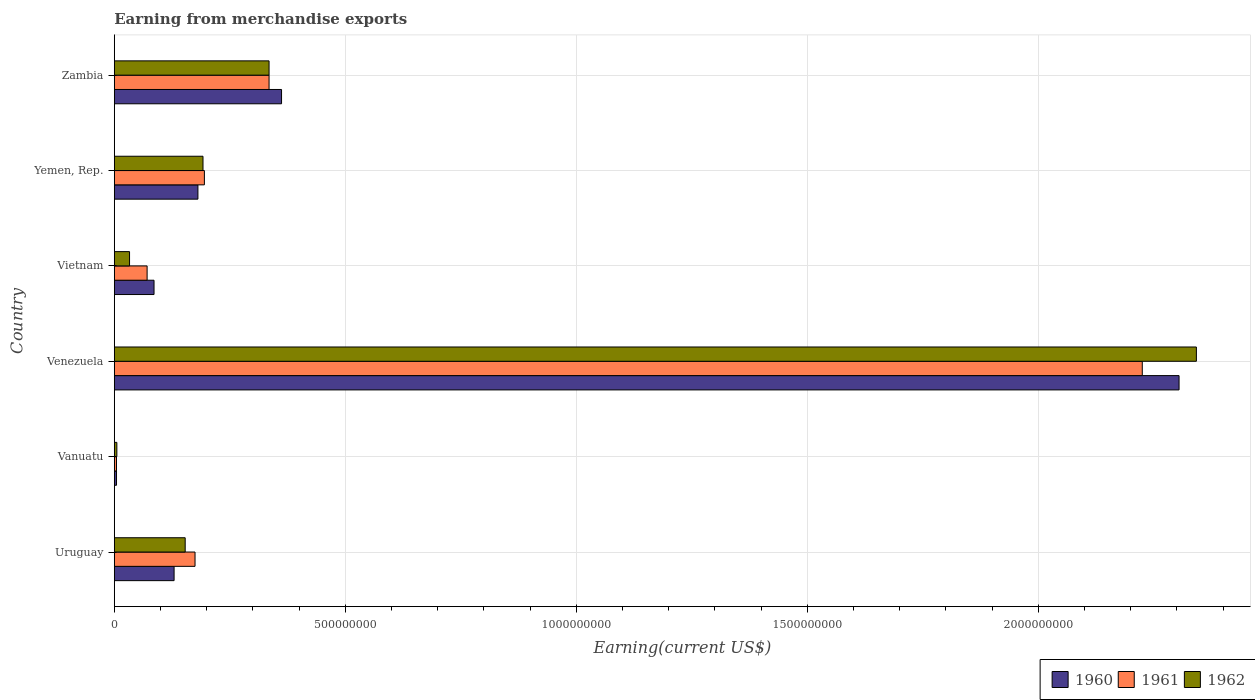How many different coloured bars are there?
Offer a terse response. 3. How many groups of bars are there?
Provide a succinct answer. 6. How many bars are there on the 5th tick from the bottom?
Give a very brief answer. 3. What is the label of the 5th group of bars from the top?
Provide a short and direct response. Vanuatu. In how many cases, is the number of bars for a given country not equal to the number of legend labels?
Provide a succinct answer. 0. What is the amount earned from merchandise exports in 1960 in Venezuela?
Give a very brief answer. 2.30e+09. Across all countries, what is the maximum amount earned from merchandise exports in 1961?
Make the answer very short. 2.23e+09. Across all countries, what is the minimum amount earned from merchandise exports in 1960?
Provide a short and direct response. 4.78e+06. In which country was the amount earned from merchandise exports in 1960 maximum?
Provide a succinct answer. Venezuela. In which country was the amount earned from merchandise exports in 1962 minimum?
Offer a terse response. Vanuatu. What is the total amount earned from merchandise exports in 1960 in the graph?
Your answer should be compact. 3.07e+09. What is the difference between the amount earned from merchandise exports in 1960 in Vietnam and that in Yemen, Rep.?
Make the answer very short. -9.50e+07. What is the difference between the amount earned from merchandise exports in 1962 in Uruguay and the amount earned from merchandise exports in 1961 in Vanuatu?
Your answer should be very brief. 1.49e+08. What is the average amount earned from merchandise exports in 1962 per country?
Keep it short and to the point. 5.10e+08. What is the difference between the amount earned from merchandise exports in 1962 and amount earned from merchandise exports in 1961 in Vietnam?
Give a very brief answer. -3.80e+07. In how many countries, is the amount earned from merchandise exports in 1961 greater than 2000000000 US$?
Keep it short and to the point. 1. What is the ratio of the amount earned from merchandise exports in 1961 in Uruguay to that in Vanuatu?
Your answer should be compact. 36.96. Is the amount earned from merchandise exports in 1962 in Vietnam less than that in Yemen, Rep.?
Give a very brief answer. Yes. Is the difference between the amount earned from merchandise exports in 1962 in Uruguay and Zambia greater than the difference between the amount earned from merchandise exports in 1961 in Uruguay and Zambia?
Offer a terse response. No. What is the difference between the highest and the second highest amount earned from merchandise exports in 1961?
Offer a terse response. 1.89e+09. What is the difference between the highest and the lowest amount earned from merchandise exports in 1960?
Your answer should be compact. 2.30e+09. In how many countries, is the amount earned from merchandise exports in 1961 greater than the average amount earned from merchandise exports in 1961 taken over all countries?
Offer a terse response. 1. Is the sum of the amount earned from merchandise exports in 1961 in Vanuatu and Yemen, Rep. greater than the maximum amount earned from merchandise exports in 1962 across all countries?
Ensure brevity in your answer.  No. What does the 1st bar from the bottom in Venezuela represents?
Provide a succinct answer. 1960. Is it the case that in every country, the sum of the amount earned from merchandise exports in 1960 and amount earned from merchandise exports in 1962 is greater than the amount earned from merchandise exports in 1961?
Offer a terse response. Yes. How many bars are there?
Offer a very short reply. 18. How many countries are there in the graph?
Your response must be concise. 6. What is the difference between two consecutive major ticks on the X-axis?
Your answer should be very brief. 5.00e+08. Are the values on the major ticks of X-axis written in scientific E-notation?
Keep it short and to the point. No. Does the graph contain any zero values?
Ensure brevity in your answer.  No. Where does the legend appear in the graph?
Provide a short and direct response. Bottom right. How many legend labels are there?
Keep it short and to the point. 3. How are the legend labels stacked?
Keep it short and to the point. Horizontal. What is the title of the graph?
Make the answer very short. Earning from merchandise exports. What is the label or title of the X-axis?
Offer a terse response. Earning(current US$). What is the Earning(current US$) in 1960 in Uruguay?
Your answer should be very brief. 1.29e+08. What is the Earning(current US$) in 1961 in Uruguay?
Provide a succinct answer. 1.75e+08. What is the Earning(current US$) in 1962 in Uruguay?
Your response must be concise. 1.53e+08. What is the Earning(current US$) in 1960 in Vanuatu?
Your answer should be compact. 4.78e+06. What is the Earning(current US$) of 1961 in Vanuatu?
Offer a terse response. 4.73e+06. What is the Earning(current US$) of 1962 in Vanuatu?
Your answer should be very brief. 5.52e+06. What is the Earning(current US$) in 1960 in Venezuela?
Offer a very short reply. 2.30e+09. What is the Earning(current US$) of 1961 in Venezuela?
Keep it short and to the point. 2.23e+09. What is the Earning(current US$) of 1962 in Venezuela?
Make the answer very short. 2.34e+09. What is the Earning(current US$) of 1960 in Vietnam?
Provide a succinct answer. 8.60e+07. What is the Earning(current US$) in 1961 in Vietnam?
Keep it short and to the point. 7.10e+07. What is the Earning(current US$) of 1962 in Vietnam?
Your answer should be compact. 3.30e+07. What is the Earning(current US$) in 1960 in Yemen, Rep.?
Your response must be concise. 1.81e+08. What is the Earning(current US$) of 1961 in Yemen, Rep.?
Ensure brevity in your answer.  1.95e+08. What is the Earning(current US$) of 1962 in Yemen, Rep.?
Provide a succinct answer. 1.92e+08. What is the Earning(current US$) of 1960 in Zambia?
Your answer should be very brief. 3.62e+08. What is the Earning(current US$) of 1961 in Zambia?
Your response must be concise. 3.35e+08. What is the Earning(current US$) of 1962 in Zambia?
Provide a short and direct response. 3.35e+08. Across all countries, what is the maximum Earning(current US$) in 1960?
Give a very brief answer. 2.30e+09. Across all countries, what is the maximum Earning(current US$) in 1961?
Your answer should be compact. 2.23e+09. Across all countries, what is the maximum Earning(current US$) of 1962?
Give a very brief answer. 2.34e+09. Across all countries, what is the minimum Earning(current US$) in 1960?
Keep it short and to the point. 4.78e+06. Across all countries, what is the minimum Earning(current US$) in 1961?
Provide a short and direct response. 4.73e+06. Across all countries, what is the minimum Earning(current US$) in 1962?
Offer a terse response. 5.52e+06. What is the total Earning(current US$) in 1960 in the graph?
Offer a terse response. 3.07e+09. What is the total Earning(current US$) of 1961 in the graph?
Keep it short and to the point. 3.01e+09. What is the total Earning(current US$) in 1962 in the graph?
Ensure brevity in your answer.  3.06e+09. What is the difference between the Earning(current US$) of 1960 in Uruguay and that in Vanuatu?
Make the answer very short. 1.25e+08. What is the difference between the Earning(current US$) in 1961 in Uruguay and that in Vanuatu?
Provide a short and direct response. 1.70e+08. What is the difference between the Earning(current US$) in 1962 in Uruguay and that in Vanuatu?
Offer a very short reply. 1.48e+08. What is the difference between the Earning(current US$) of 1960 in Uruguay and that in Venezuela?
Your answer should be compact. -2.18e+09. What is the difference between the Earning(current US$) of 1961 in Uruguay and that in Venezuela?
Your response must be concise. -2.05e+09. What is the difference between the Earning(current US$) of 1962 in Uruguay and that in Venezuela?
Make the answer very short. -2.19e+09. What is the difference between the Earning(current US$) of 1960 in Uruguay and that in Vietnam?
Offer a very short reply. 4.34e+07. What is the difference between the Earning(current US$) in 1961 in Uruguay and that in Vietnam?
Keep it short and to the point. 1.04e+08. What is the difference between the Earning(current US$) in 1962 in Uruguay and that in Vietnam?
Keep it short and to the point. 1.20e+08. What is the difference between the Earning(current US$) in 1960 in Uruguay and that in Yemen, Rep.?
Give a very brief answer. -5.16e+07. What is the difference between the Earning(current US$) in 1961 in Uruguay and that in Yemen, Rep.?
Offer a terse response. -2.03e+07. What is the difference between the Earning(current US$) in 1962 in Uruguay and that in Yemen, Rep.?
Offer a terse response. -3.86e+07. What is the difference between the Earning(current US$) in 1960 in Uruguay and that in Zambia?
Offer a terse response. -2.33e+08. What is the difference between the Earning(current US$) of 1961 in Uruguay and that in Zambia?
Offer a very short reply. -1.60e+08. What is the difference between the Earning(current US$) of 1962 in Uruguay and that in Zambia?
Give a very brief answer. -1.82e+08. What is the difference between the Earning(current US$) of 1960 in Vanuatu and that in Venezuela?
Ensure brevity in your answer.  -2.30e+09. What is the difference between the Earning(current US$) in 1961 in Vanuatu and that in Venezuela?
Your response must be concise. -2.22e+09. What is the difference between the Earning(current US$) of 1962 in Vanuatu and that in Venezuela?
Provide a short and direct response. -2.34e+09. What is the difference between the Earning(current US$) in 1960 in Vanuatu and that in Vietnam?
Make the answer very short. -8.12e+07. What is the difference between the Earning(current US$) of 1961 in Vanuatu and that in Vietnam?
Provide a succinct answer. -6.63e+07. What is the difference between the Earning(current US$) of 1962 in Vanuatu and that in Vietnam?
Provide a short and direct response. -2.75e+07. What is the difference between the Earning(current US$) in 1960 in Vanuatu and that in Yemen, Rep.?
Offer a terse response. -1.76e+08. What is the difference between the Earning(current US$) of 1961 in Vanuatu and that in Yemen, Rep.?
Offer a terse response. -1.90e+08. What is the difference between the Earning(current US$) in 1962 in Vanuatu and that in Yemen, Rep.?
Give a very brief answer. -1.86e+08. What is the difference between the Earning(current US$) of 1960 in Vanuatu and that in Zambia?
Make the answer very short. -3.57e+08. What is the difference between the Earning(current US$) of 1961 in Vanuatu and that in Zambia?
Offer a terse response. -3.30e+08. What is the difference between the Earning(current US$) in 1962 in Vanuatu and that in Zambia?
Your answer should be very brief. -3.29e+08. What is the difference between the Earning(current US$) in 1960 in Venezuela and that in Vietnam?
Ensure brevity in your answer.  2.22e+09. What is the difference between the Earning(current US$) of 1961 in Venezuela and that in Vietnam?
Your answer should be compact. 2.15e+09. What is the difference between the Earning(current US$) of 1962 in Venezuela and that in Vietnam?
Your answer should be very brief. 2.31e+09. What is the difference between the Earning(current US$) in 1960 in Venezuela and that in Yemen, Rep.?
Provide a short and direct response. 2.12e+09. What is the difference between the Earning(current US$) in 1961 in Venezuela and that in Yemen, Rep.?
Provide a short and direct response. 2.03e+09. What is the difference between the Earning(current US$) of 1962 in Venezuela and that in Yemen, Rep.?
Make the answer very short. 2.15e+09. What is the difference between the Earning(current US$) of 1960 in Venezuela and that in Zambia?
Give a very brief answer. 1.94e+09. What is the difference between the Earning(current US$) in 1961 in Venezuela and that in Zambia?
Keep it short and to the point. 1.89e+09. What is the difference between the Earning(current US$) of 1962 in Venezuela and that in Zambia?
Ensure brevity in your answer.  2.01e+09. What is the difference between the Earning(current US$) of 1960 in Vietnam and that in Yemen, Rep.?
Your answer should be compact. -9.50e+07. What is the difference between the Earning(current US$) of 1961 in Vietnam and that in Yemen, Rep.?
Keep it short and to the point. -1.24e+08. What is the difference between the Earning(current US$) in 1962 in Vietnam and that in Yemen, Rep.?
Provide a succinct answer. -1.59e+08. What is the difference between the Earning(current US$) in 1960 in Vietnam and that in Zambia?
Ensure brevity in your answer.  -2.76e+08. What is the difference between the Earning(current US$) of 1961 in Vietnam and that in Zambia?
Offer a terse response. -2.64e+08. What is the difference between the Earning(current US$) of 1962 in Vietnam and that in Zambia?
Your response must be concise. -3.02e+08. What is the difference between the Earning(current US$) in 1960 in Yemen, Rep. and that in Zambia?
Offer a terse response. -1.81e+08. What is the difference between the Earning(current US$) in 1961 in Yemen, Rep. and that in Zambia?
Your response must be concise. -1.40e+08. What is the difference between the Earning(current US$) in 1962 in Yemen, Rep. and that in Zambia?
Offer a very short reply. -1.43e+08. What is the difference between the Earning(current US$) in 1960 in Uruguay and the Earning(current US$) in 1961 in Vanuatu?
Ensure brevity in your answer.  1.25e+08. What is the difference between the Earning(current US$) in 1960 in Uruguay and the Earning(current US$) in 1962 in Vanuatu?
Provide a succinct answer. 1.24e+08. What is the difference between the Earning(current US$) in 1961 in Uruguay and the Earning(current US$) in 1962 in Vanuatu?
Your answer should be very brief. 1.69e+08. What is the difference between the Earning(current US$) of 1960 in Uruguay and the Earning(current US$) of 1961 in Venezuela?
Ensure brevity in your answer.  -2.10e+09. What is the difference between the Earning(current US$) of 1960 in Uruguay and the Earning(current US$) of 1962 in Venezuela?
Your answer should be compact. -2.21e+09. What is the difference between the Earning(current US$) of 1961 in Uruguay and the Earning(current US$) of 1962 in Venezuela?
Your answer should be compact. -2.17e+09. What is the difference between the Earning(current US$) in 1960 in Uruguay and the Earning(current US$) in 1961 in Vietnam?
Ensure brevity in your answer.  5.84e+07. What is the difference between the Earning(current US$) in 1960 in Uruguay and the Earning(current US$) in 1962 in Vietnam?
Offer a very short reply. 9.64e+07. What is the difference between the Earning(current US$) of 1961 in Uruguay and the Earning(current US$) of 1962 in Vietnam?
Ensure brevity in your answer.  1.42e+08. What is the difference between the Earning(current US$) in 1960 in Uruguay and the Earning(current US$) in 1961 in Yemen, Rep.?
Offer a very short reply. -6.56e+07. What is the difference between the Earning(current US$) in 1960 in Uruguay and the Earning(current US$) in 1962 in Yemen, Rep.?
Your answer should be compact. -6.26e+07. What is the difference between the Earning(current US$) in 1961 in Uruguay and the Earning(current US$) in 1962 in Yemen, Rep.?
Keep it short and to the point. -1.73e+07. What is the difference between the Earning(current US$) in 1960 in Uruguay and the Earning(current US$) in 1961 in Zambia?
Provide a short and direct response. -2.06e+08. What is the difference between the Earning(current US$) of 1960 in Uruguay and the Earning(current US$) of 1962 in Zambia?
Provide a short and direct response. -2.06e+08. What is the difference between the Earning(current US$) in 1961 in Uruguay and the Earning(current US$) in 1962 in Zambia?
Provide a succinct answer. -1.60e+08. What is the difference between the Earning(current US$) of 1960 in Vanuatu and the Earning(current US$) of 1961 in Venezuela?
Offer a terse response. -2.22e+09. What is the difference between the Earning(current US$) of 1960 in Vanuatu and the Earning(current US$) of 1962 in Venezuela?
Your answer should be very brief. -2.34e+09. What is the difference between the Earning(current US$) of 1961 in Vanuatu and the Earning(current US$) of 1962 in Venezuela?
Provide a succinct answer. -2.34e+09. What is the difference between the Earning(current US$) in 1960 in Vanuatu and the Earning(current US$) in 1961 in Vietnam?
Make the answer very short. -6.62e+07. What is the difference between the Earning(current US$) of 1960 in Vanuatu and the Earning(current US$) of 1962 in Vietnam?
Provide a short and direct response. -2.82e+07. What is the difference between the Earning(current US$) of 1961 in Vanuatu and the Earning(current US$) of 1962 in Vietnam?
Your answer should be very brief. -2.83e+07. What is the difference between the Earning(current US$) in 1960 in Vanuatu and the Earning(current US$) in 1961 in Yemen, Rep.?
Provide a short and direct response. -1.90e+08. What is the difference between the Earning(current US$) in 1960 in Vanuatu and the Earning(current US$) in 1962 in Yemen, Rep.?
Make the answer very short. -1.87e+08. What is the difference between the Earning(current US$) in 1961 in Vanuatu and the Earning(current US$) in 1962 in Yemen, Rep.?
Give a very brief answer. -1.87e+08. What is the difference between the Earning(current US$) in 1960 in Vanuatu and the Earning(current US$) in 1961 in Zambia?
Offer a terse response. -3.30e+08. What is the difference between the Earning(current US$) in 1960 in Vanuatu and the Earning(current US$) in 1962 in Zambia?
Provide a succinct answer. -3.30e+08. What is the difference between the Earning(current US$) of 1961 in Vanuatu and the Earning(current US$) of 1962 in Zambia?
Make the answer very short. -3.30e+08. What is the difference between the Earning(current US$) in 1960 in Venezuela and the Earning(current US$) in 1961 in Vietnam?
Offer a very short reply. 2.23e+09. What is the difference between the Earning(current US$) in 1960 in Venezuela and the Earning(current US$) in 1962 in Vietnam?
Provide a succinct answer. 2.27e+09. What is the difference between the Earning(current US$) in 1961 in Venezuela and the Earning(current US$) in 1962 in Vietnam?
Give a very brief answer. 2.19e+09. What is the difference between the Earning(current US$) of 1960 in Venezuela and the Earning(current US$) of 1961 in Yemen, Rep.?
Offer a terse response. 2.11e+09. What is the difference between the Earning(current US$) in 1960 in Venezuela and the Earning(current US$) in 1962 in Yemen, Rep.?
Give a very brief answer. 2.11e+09. What is the difference between the Earning(current US$) in 1961 in Venezuela and the Earning(current US$) in 1962 in Yemen, Rep.?
Make the answer very short. 2.03e+09. What is the difference between the Earning(current US$) in 1960 in Venezuela and the Earning(current US$) in 1961 in Zambia?
Provide a succinct answer. 1.97e+09. What is the difference between the Earning(current US$) in 1960 in Venezuela and the Earning(current US$) in 1962 in Zambia?
Your answer should be very brief. 1.97e+09. What is the difference between the Earning(current US$) of 1961 in Venezuela and the Earning(current US$) of 1962 in Zambia?
Give a very brief answer. 1.89e+09. What is the difference between the Earning(current US$) in 1960 in Vietnam and the Earning(current US$) in 1961 in Yemen, Rep.?
Keep it short and to the point. -1.09e+08. What is the difference between the Earning(current US$) of 1960 in Vietnam and the Earning(current US$) of 1962 in Yemen, Rep.?
Offer a terse response. -1.06e+08. What is the difference between the Earning(current US$) in 1961 in Vietnam and the Earning(current US$) in 1962 in Yemen, Rep.?
Provide a short and direct response. -1.21e+08. What is the difference between the Earning(current US$) of 1960 in Vietnam and the Earning(current US$) of 1961 in Zambia?
Your answer should be compact. -2.49e+08. What is the difference between the Earning(current US$) in 1960 in Vietnam and the Earning(current US$) in 1962 in Zambia?
Your response must be concise. -2.49e+08. What is the difference between the Earning(current US$) of 1961 in Vietnam and the Earning(current US$) of 1962 in Zambia?
Provide a succinct answer. -2.64e+08. What is the difference between the Earning(current US$) in 1960 in Yemen, Rep. and the Earning(current US$) in 1961 in Zambia?
Your answer should be very brief. -1.54e+08. What is the difference between the Earning(current US$) of 1960 in Yemen, Rep. and the Earning(current US$) of 1962 in Zambia?
Give a very brief answer. -1.54e+08. What is the difference between the Earning(current US$) in 1961 in Yemen, Rep. and the Earning(current US$) in 1962 in Zambia?
Your answer should be very brief. -1.40e+08. What is the average Earning(current US$) of 1960 per country?
Give a very brief answer. 5.11e+08. What is the average Earning(current US$) in 1961 per country?
Ensure brevity in your answer.  5.01e+08. What is the average Earning(current US$) of 1962 per country?
Give a very brief answer. 5.10e+08. What is the difference between the Earning(current US$) of 1960 and Earning(current US$) of 1961 in Uruguay?
Your response must be concise. -4.53e+07. What is the difference between the Earning(current US$) of 1960 and Earning(current US$) of 1962 in Uruguay?
Provide a short and direct response. -2.40e+07. What is the difference between the Earning(current US$) in 1961 and Earning(current US$) in 1962 in Uruguay?
Your answer should be compact. 2.13e+07. What is the difference between the Earning(current US$) of 1960 and Earning(current US$) of 1961 in Vanuatu?
Offer a very short reply. 5.01e+04. What is the difference between the Earning(current US$) of 1960 and Earning(current US$) of 1962 in Vanuatu?
Ensure brevity in your answer.  -7.43e+05. What is the difference between the Earning(current US$) of 1961 and Earning(current US$) of 1962 in Vanuatu?
Provide a short and direct response. -7.93e+05. What is the difference between the Earning(current US$) in 1960 and Earning(current US$) in 1961 in Venezuela?
Make the answer very short. 7.96e+07. What is the difference between the Earning(current US$) of 1960 and Earning(current US$) of 1962 in Venezuela?
Offer a very short reply. -3.75e+07. What is the difference between the Earning(current US$) of 1961 and Earning(current US$) of 1962 in Venezuela?
Your answer should be very brief. -1.17e+08. What is the difference between the Earning(current US$) of 1960 and Earning(current US$) of 1961 in Vietnam?
Your answer should be very brief. 1.50e+07. What is the difference between the Earning(current US$) in 1960 and Earning(current US$) in 1962 in Vietnam?
Your answer should be compact. 5.30e+07. What is the difference between the Earning(current US$) of 1961 and Earning(current US$) of 1962 in Vietnam?
Provide a short and direct response. 3.80e+07. What is the difference between the Earning(current US$) of 1960 and Earning(current US$) of 1961 in Yemen, Rep.?
Keep it short and to the point. -1.40e+07. What is the difference between the Earning(current US$) in 1960 and Earning(current US$) in 1962 in Yemen, Rep.?
Ensure brevity in your answer.  -1.10e+07. What is the difference between the Earning(current US$) in 1961 and Earning(current US$) in 1962 in Yemen, Rep.?
Offer a terse response. 3.00e+06. What is the difference between the Earning(current US$) of 1960 and Earning(current US$) of 1961 in Zambia?
Give a very brief answer. 2.70e+07. What is the difference between the Earning(current US$) in 1960 and Earning(current US$) in 1962 in Zambia?
Your response must be concise. 2.70e+07. What is the difference between the Earning(current US$) in 1961 and Earning(current US$) in 1962 in Zambia?
Your answer should be very brief. 0. What is the ratio of the Earning(current US$) in 1960 in Uruguay to that in Vanuatu?
Ensure brevity in your answer.  27.08. What is the ratio of the Earning(current US$) in 1961 in Uruguay to that in Vanuatu?
Give a very brief answer. 36.96. What is the ratio of the Earning(current US$) in 1962 in Uruguay to that in Vanuatu?
Your response must be concise. 27.79. What is the ratio of the Earning(current US$) of 1960 in Uruguay to that in Venezuela?
Offer a terse response. 0.06. What is the ratio of the Earning(current US$) of 1961 in Uruguay to that in Venezuela?
Ensure brevity in your answer.  0.08. What is the ratio of the Earning(current US$) of 1962 in Uruguay to that in Venezuela?
Give a very brief answer. 0.07. What is the ratio of the Earning(current US$) in 1960 in Uruguay to that in Vietnam?
Keep it short and to the point. 1.5. What is the ratio of the Earning(current US$) in 1961 in Uruguay to that in Vietnam?
Make the answer very short. 2.46. What is the ratio of the Earning(current US$) in 1962 in Uruguay to that in Vietnam?
Ensure brevity in your answer.  4.65. What is the ratio of the Earning(current US$) of 1960 in Uruguay to that in Yemen, Rep.?
Offer a terse response. 0.71. What is the ratio of the Earning(current US$) in 1961 in Uruguay to that in Yemen, Rep.?
Provide a short and direct response. 0.9. What is the ratio of the Earning(current US$) of 1962 in Uruguay to that in Yemen, Rep.?
Ensure brevity in your answer.  0.8. What is the ratio of the Earning(current US$) of 1960 in Uruguay to that in Zambia?
Provide a short and direct response. 0.36. What is the ratio of the Earning(current US$) of 1961 in Uruguay to that in Zambia?
Give a very brief answer. 0.52. What is the ratio of the Earning(current US$) in 1962 in Uruguay to that in Zambia?
Your answer should be very brief. 0.46. What is the ratio of the Earning(current US$) in 1960 in Vanuatu to that in Venezuela?
Your answer should be compact. 0. What is the ratio of the Earning(current US$) in 1961 in Vanuatu to that in Venezuela?
Ensure brevity in your answer.  0. What is the ratio of the Earning(current US$) of 1962 in Vanuatu to that in Venezuela?
Provide a short and direct response. 0. What is the ratio of the Earning(current US$) of 1960 in Vanuatu to that in Vietnam?
Offer a very short reply. 0.06. What is the ratio of the Earning(current US$) of 1961 in Vanuatu to that in Vietnam?
Offer a terse response. 0.07. What is the ratio of the Earning(current US$) of 1962 in Vanuatu to that in Vietnam?
Your answer should be very brief. 0.17. What is the ratio of the Earning(current US$) of 1960 in Vanuatu to that in Yemen, Rep.?
Ensure brevity in your answer.  0.03. What is the ratio of the Earning(current US$) of 1961 in Vanuatu to that in Yemen, Rep.?
Your answer should be very brief. 0.02. What is the ratio of the Earning(current US$) in 1962 in Vanuatu to that in Yemen, Rep.?
Make the answer very short. 0.03. What is the ratio of the Earning(current US$) in 1960 in Vanuatu to that in Zambia?
Give a very brief answer. 0.01. What is the ratio of the Earning(current US$) of 1961 in Vanuatu to that in Zambia?
Give a very brief answer. 0.01. What is the ratio of the Earning(current US$) of 1962 in Vanuatu to that in Zambia?
Your response must be concise. 0.02. What is the ratio of the Earning(current US$) in 1960 in Venezuela to that in Vietnam?
Offer a very short reply. 26.8. What is the ratio of the Earning(current US$) in 1961 in Venezuela to that in Vietnam?
Ensure brevity in your answer.  31.34. What is the ratio of the Earning(current US$) in 1962 in Venezuela to that in Vietnam?
Offer a very short reply. 70.98. What is the ratio of the Earning(current US$) of 1960 in Venezuela to that in Yemen, Rep.?
Make the answer very short. 12.73. What is the ratio of the Earning(current US$) of 1961 in Venezuela to that in Yemen, Rep.?
Make the answer very short. 11.41. What is the ratio of the Earning(current US$) in 1962 in Venezuela to that in Yemen, Rep.?
Offer a very short reply. 12.2. What is the ratio of the Earning(current US$) of 1960 in Venezuela to that in Zambia?
Provide a short and direct response. 6.37. What is the ratio of the Earning(current US$) in 1961 in Venezuela to that in Zambia?
Offer a very short reply. 6.64. What is the ratio of the Earning(current US$) in 1962 in Venezuela to that in Zambia?
Your response must be concise. 6.99. What is the ratio of the Earning(current US$) in 1960 in Vietnam to that in Yemen, Rep.?
Keep it short and to the point. 0.48. What is the ratio of the Earning(current US$) in 1961 in Vietnam to that in Yemen, Rep.?
Your answer should be very brief. 0.36. What is the ratio of the Earning(current US$) in 1962 in Vietnam to that in Yemen, Rep.?
Keep it short and to the point. 0.17. What is the ratio of the Earning(current US$) in 1960 in Vietnam to that in Zambia?
Keep it short and to the point. 0.24. What is the ratio of the Earning(current US$) in 1961 in Vietnam to that in Zambia?
Offer a very short reply. 0.21. What is the ratio of the Earning(current US$) of 1962 in Vietnam to that in Zambia?
Offer a very short reply. 0.1. What is the ratio of the Earning(current US$) of 1961 in Yemen, Rep. to that in Zambia?
Give a very brief answer. 0.58. What is the ratio of the Earning(current US$) in 1962 in Yemen, Rep. to that in Zambia?
Offer a very short reply. 0.57. What is the difference between the highest and the second highest Earning(current US$) in 1960?
Give a very brief answer. 1.94e+09. What is the difference between the highest and the second highest Earning(current US$) of 1961?
Your answer should be compact. 1.89e+09. What is the difference between the highest and the second highest Earning(current US$) in 1962?
Offer a very short reply. 2.01e+09. What is the difference between the highest and the lowest Earning(current US$) of 1960?
Offer a terse response. 2.30e+09. What is the difference between the highest and the lowest Earning(current US$) of 1961?
Provide a short and direct response. 2.22e+09. What is the difference between the highest and the lowest Earning(current US$) in 1962?
Offer a terse response. 2.34e+09. 